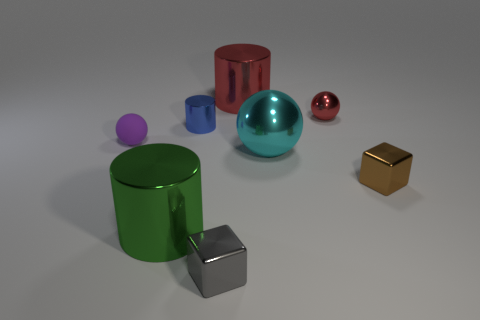Can you tell me how many objects are in this image, and which one is the largest? There are seven objects in the image. The largest object appears to be the green cylinder. What does the surface of the objects look like? The surfaces are highly reflective, suggesting that the objects are possibly made from a metallic material, with a smooth, glossy finish. 